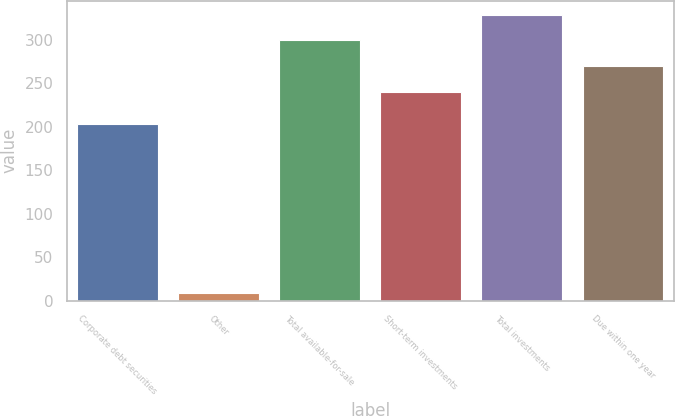Convert chart to OTSL. <chart><loc_0><loc_0><loc_500><loc_500><bar_chart><fcel>Corporate debt securities<fcel>Other<fcel>Total available-for-sale<fcel>Short-term investments<fcel>Total investments<fcel>Due within one year<nl><fcel>203.1<fcel>8.6<fcel>299.7<fcel>240.4<fcel>328.81<fcel>269.51<nl></chart> 